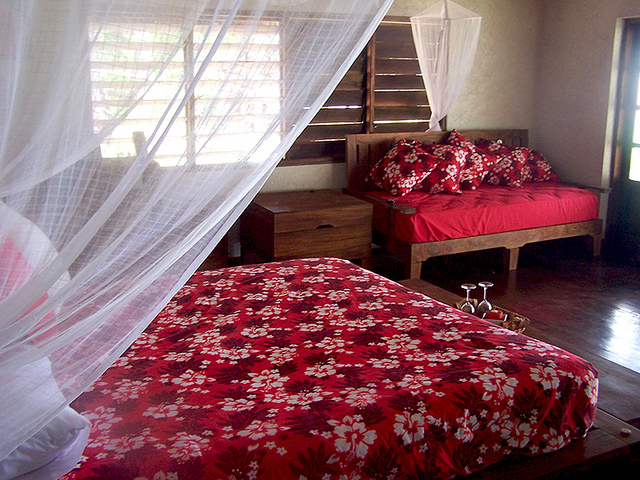What type of furniture piece is in the corner? In the corner of the room, there is a double bed adorned with a vibrant red and white floral bedspread, accentuating the rustic charm of the space. 